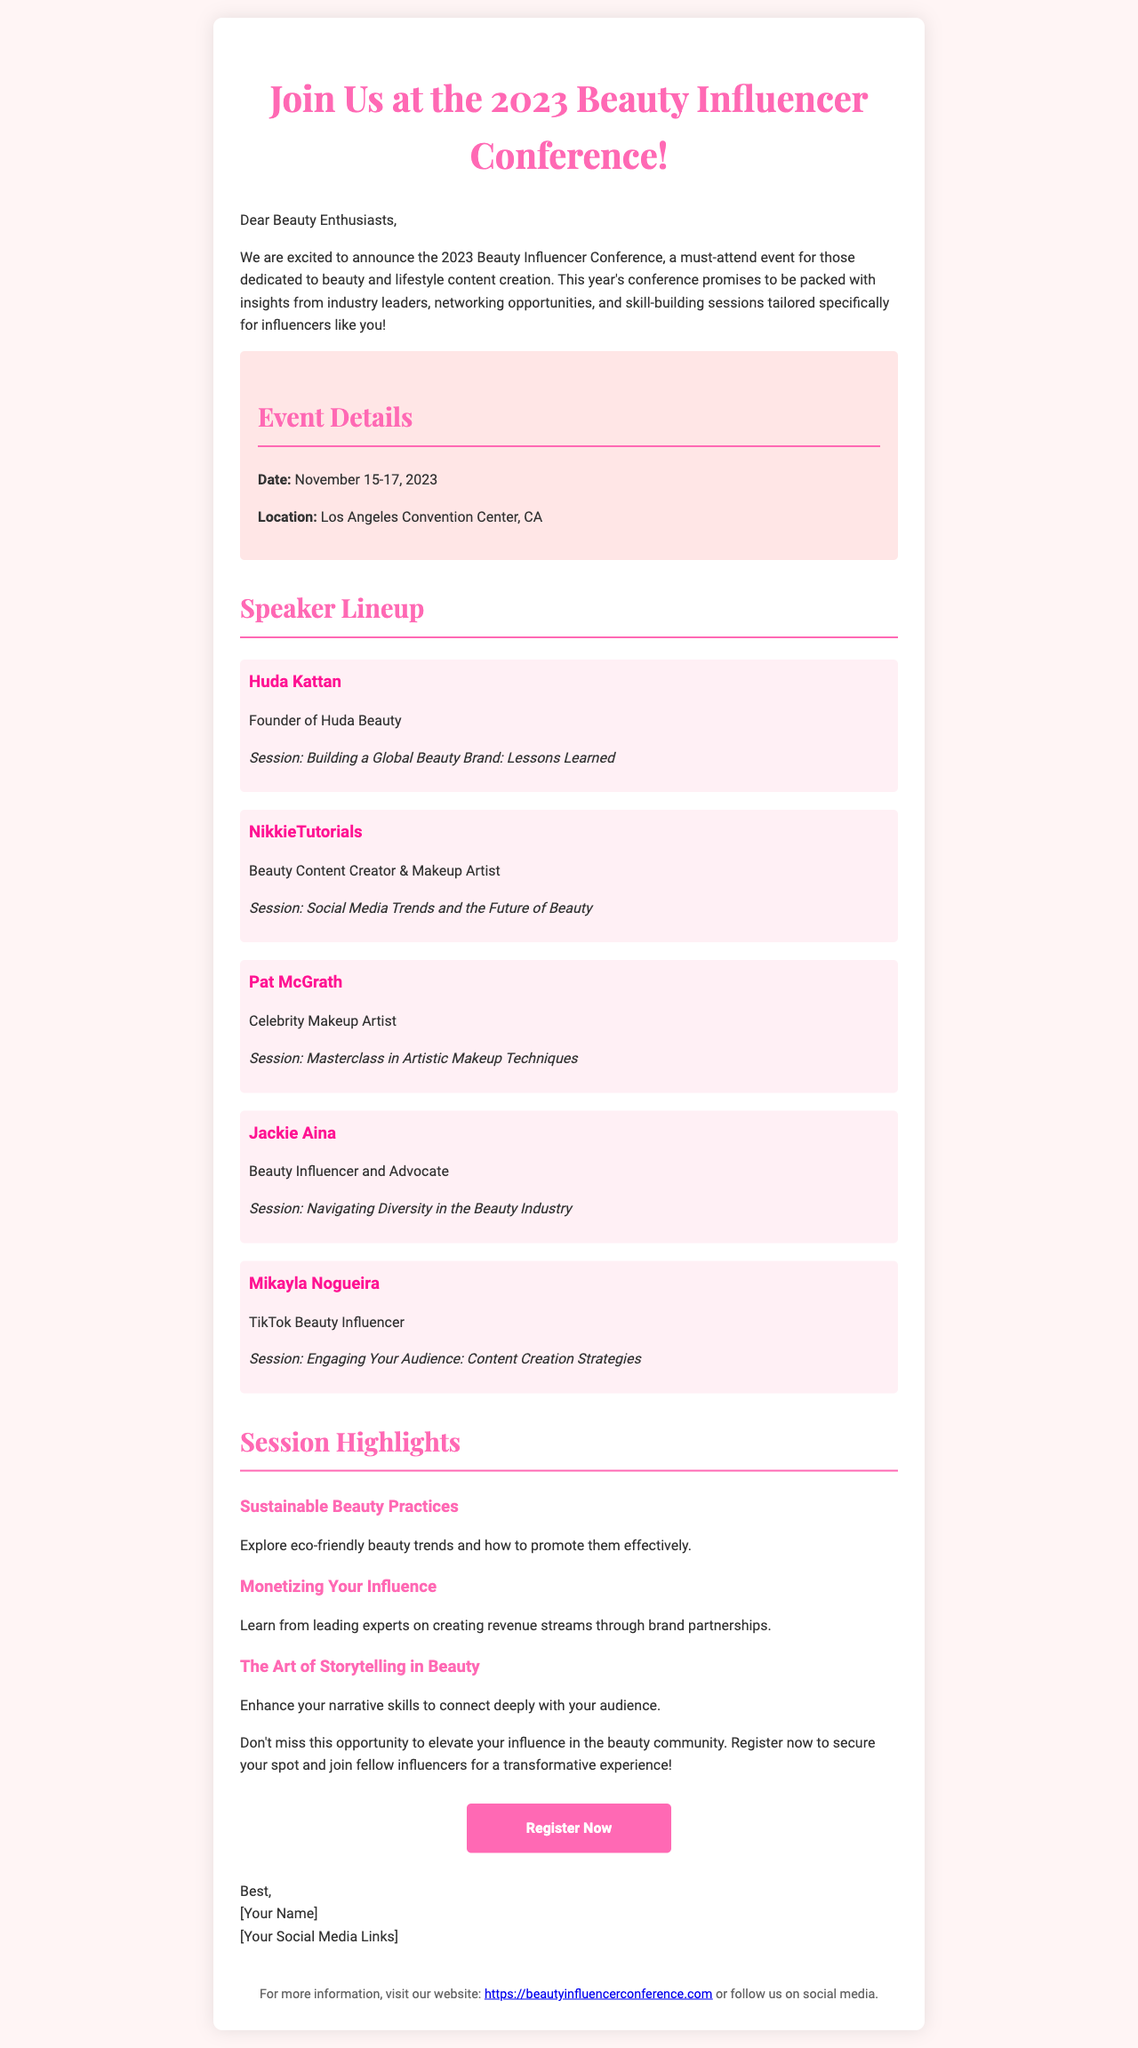What are the dates of the conference? The dates for the 2023 Beauty Influencer Conference are mentioned in the event details section.
Answer: November 15-17, 2023 Who is the founder of Huda Beauty? The document lists Huda Kattan as a speaker and identifies her as the founder of Huda Beauty.
Answer: Huda Kattan What session will Pat McGrath lead? The document specifies the session led by Pat McGrath among the speaker details.
Answer: Masterclass in Artistic Makeup Techniques How many speakers are listed in the document? The document enumerates the speakers showcased in the speaker lineup section.
Answer: Five What is the main theme of the session titled "Sustainable Beauty Practices"? This session is about exploring eco-friendly trends and effective promotion, as described in the session highlights.
Answer: Eco-friendly beauty trends What type of venue is hosting the conference? The venue is provided in the event details, indicating the location type.
Answer: Convention Center What is the purpose of the "Register Now" button? The button is a call to action for attendees to secure their conference spot.
Answer: To register for the conference Which social media platform does Mikayla Nogueira primarily use? The document describes Mikayla Nogueira as a TikTok beauty influencer.
Answer: TikTok 